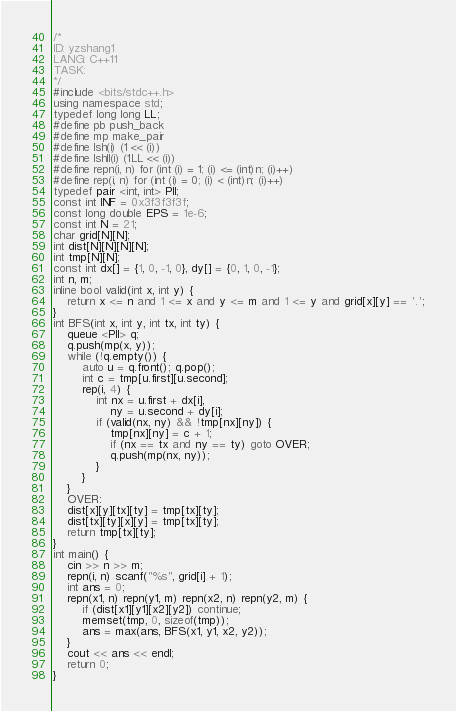Convert code to text. <code><loc_0><loc_0><loc_500><loc_500><_C++_>/*
ID: yzshang1
LANG: C++11
TASK:
*/
#include <bits/stdc++.h>
using namespace std;
typedef long long LL;
#define pb push_back
#define mp make_pair
#define lsh(i) (1 << (i))
#define lshll(i) (1LL << (i))
#define repn(i, n) for (int (i) = 1; (i) <= (int)n; (i)++)
#define rep(i, n) for (int (i) = 0; (i) < (int)n; (i)++)
typedef pair <int, int> PII;
const int INF = 0x3f3f3f3f;
const long double EPS = 1e-6;
const int N = 21;
char grid[N][N];
int dist[N][N][N][N];
int tmp[N][N];
const int dx[] = {1, 0, -1, 0}, dy[] = {0, 1, 0, -1};
int n, m;
inline bool valid(int x, int y) {
	return x <= n and 1 <= x and y <= m and 1 <= y and grid[x][y] == '.';
}
int BFS(int x, int y, int tx, int ty) {
	queue <PII> q;
	q.push(mp(x, y));
	while (!q.empty()) {
		auto u = q.front(); q.pop();
		int c = tmp[u.first][u.second];
		rep(i, 4) {
			int nx = u.first + dx[i],
				ny = u.second + dy[i];
			if (valid(nx, ny) && !tmp[nx][ny]) {
				tmp[nx][ny] = c + 1;
				if (nx == tx and ny == ty) goto OVER;
				q.push(mp(nx, ny));
			}
		}
	}
	OVER:
	dist[x][y][tx][ty] = tmp[tx][ty];
	dist[tx][ty][x][y] = tmp[tx][ty];
	return tmp[tx][ty];
}
int main() {
	cin >> n >> m;
	repn(i, n) scanf("%s", grid[i] + 1);
	int ans = 0;
	repn(x1, n) repn(y1, m) repn(x2, n) repn(y2, m) {
		if (dist[x1][y1][x2][y2]) continue;
		memset(tmp, 0, sizeof(tmp));
		ans = max(ans, BFS(x1, y1, x2, y2));
	}
	cout << ans << endl;
	return 0;
}
</code> 